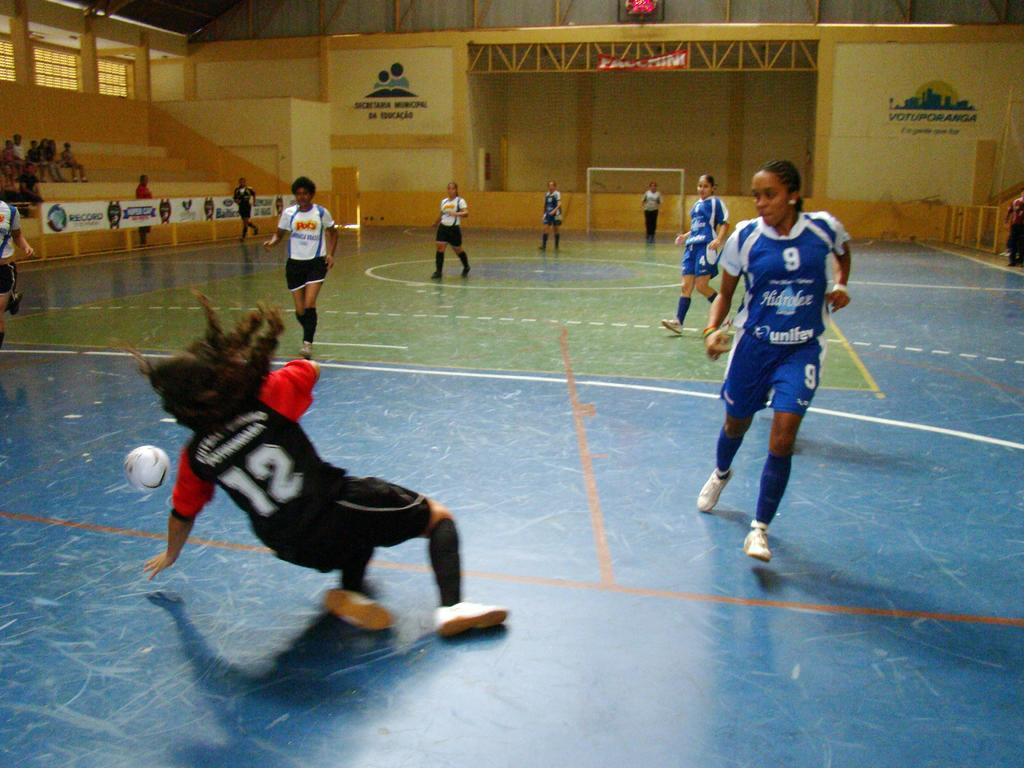<image>
Provide a brief description of the given image. Player number 12 is falling down on the floor as they go for the ball. 